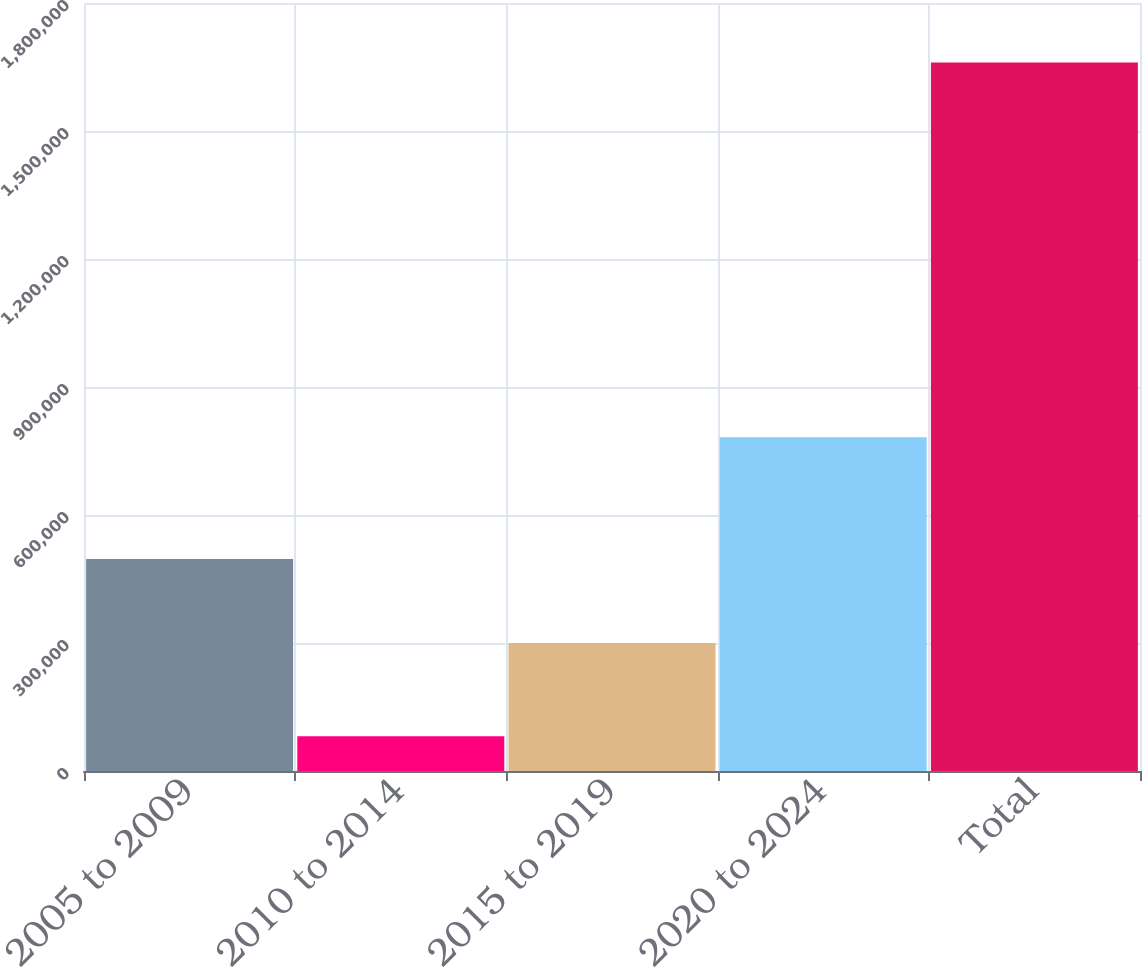Convert chart to OTSL. <chart><loc_0><loc_0><loc_500><loc_500><bar_chart><fcel>2005 to 2009<fcel>2010 to 2014<fcel>2015 to 2019<fcel>2020 to 2024<fcel>Total<nl><fcel>497122<fcel>81245<fcel>299780<fcel>782318<fcel>1.66046e+06<nl></chart> 